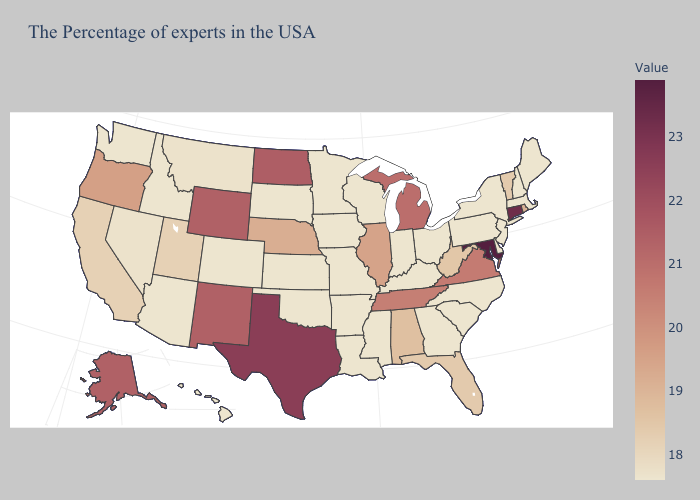Does the map have missing data?
Keep it brief. No. Does Utah have a higher value than Wyoming?
Keep it brief. No. Which states have the lowest value in the USA?
Concise answer only. Maine, Massachusetts, New Hampshire, New York, New Jersey, Delaware, Pennsylvania, North Carolina, South Carolina, Ohio, Georgia, Kentucky, Indiana, Wisconsin, Mississippi, Louisiana, Missouri, Arkansas, Minnesota, Iowa, Kansas, Oklahoma, South Dakota, Colorado, Arizona, Idaho, Washington, Hawaii. Does Connecticut have the highest value in the Northeast?
Keep it brief. Yes. Among the states that border Texas , does New Mexico have the highest value?
Quick response, please. Yes. 